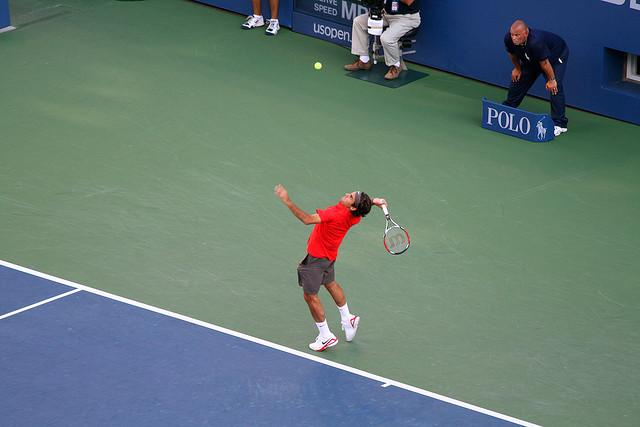What part of tennis is happening? serve 